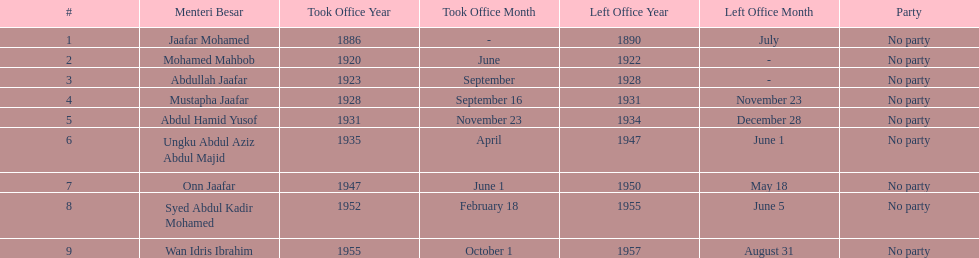Who took office after abdullah jaafar? Mustapha Jaafar. 